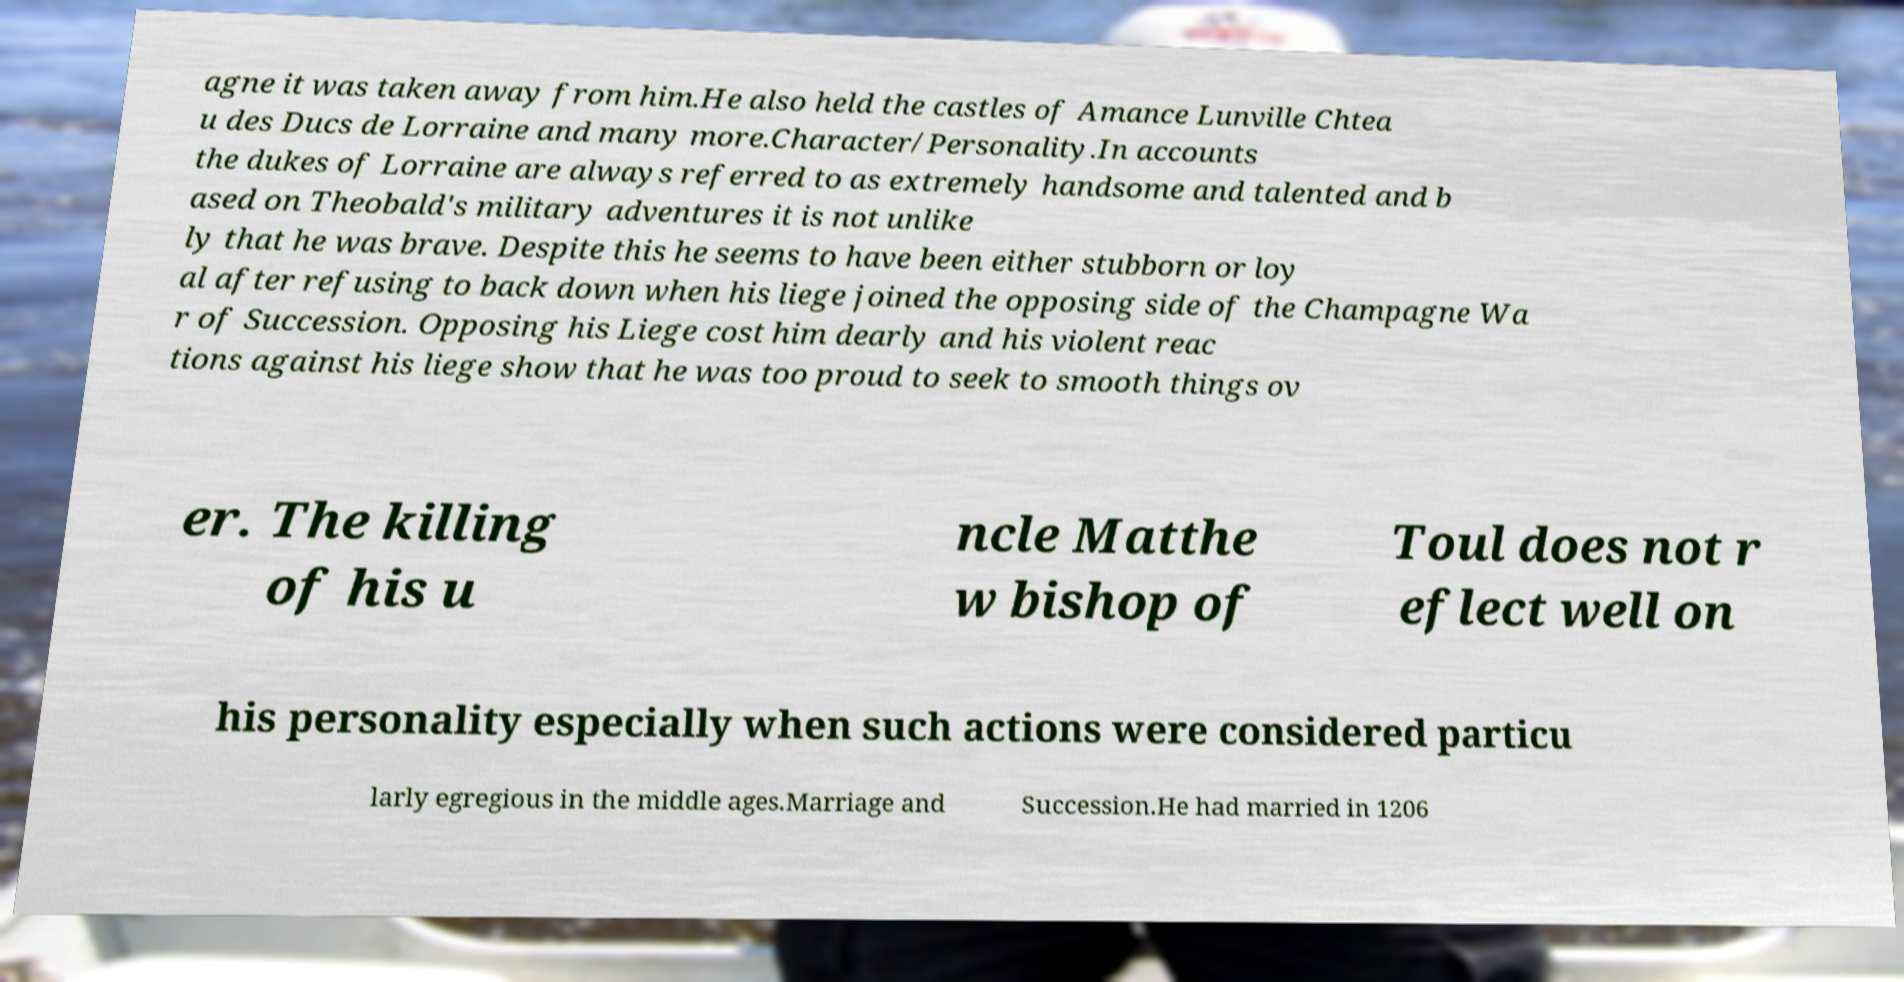There's text embedded in this image that I need extracted. Can you transcribe it verbatim? agne it was taken away from him.He also held the castles of Amance Lunville Chtea u des Ducs de Lorraine and many more.Character/Personality.In accounts the dukes of Lorraine are always referred to as extremely handsome and talented and b ased on Theobald's military adventures it is not unlike ly that he was brave. Despite this he seems to have been either stubborn or loy al after refusing to back down when his liege joined the opposing side of the Champagne Wa r of Succession. Opposing his Liege cost him dearly and his violent reac tions against his liege show that he was too proud to seek to smooth things ov er. The killing of his u ncle Matthe w bishop of Toul does not r eflect well on his personality especially when such actions were considered particu larly egregious in the middle ages.Marriage and Succession.He had married in 1206 